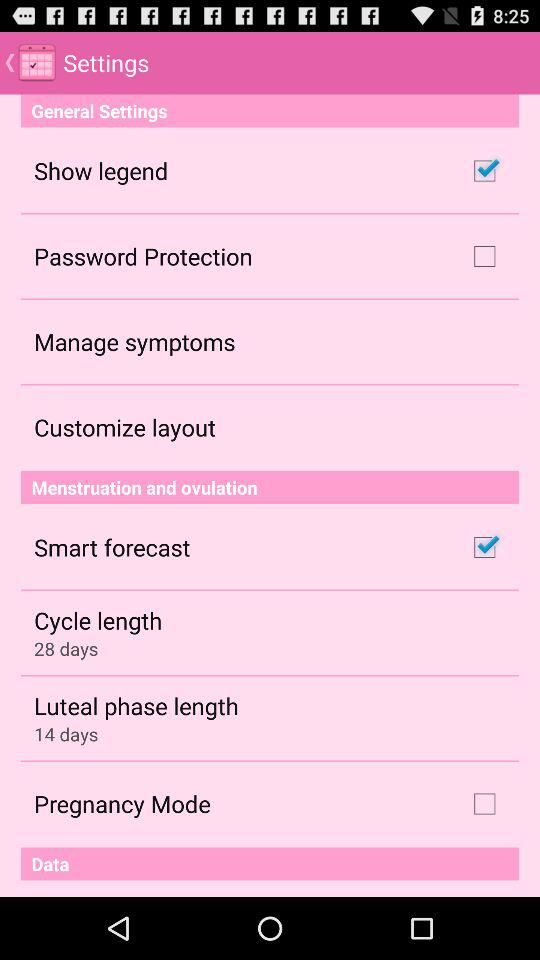What is the status of the "Pregnancy Mode" checkbox? The status of the "Pregnancy Mode" checkbox is "off". 